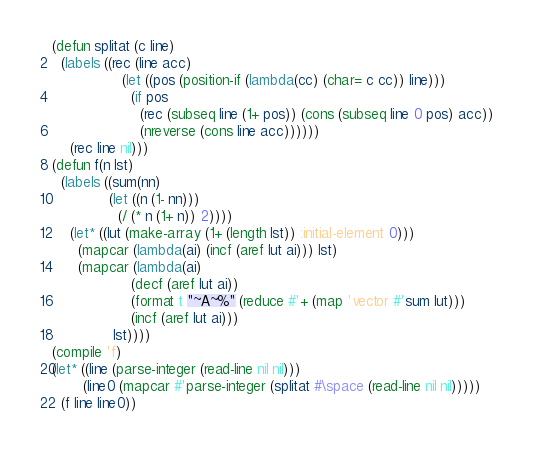Convert code to text. <code><loc_0><loc_0><loc_500><loc_500><_Lisp_>(defun splitat (c line)
  (labels ((rec (line acc)
                (let ((pos (position-if (lambda(cc) (char= c cc)) line)))
                  (if pos
                    (rec (subseq line (1+ pos)) (cons (subseq line 0 pos) acc))
                    (nreverse (cons line acc))))))
    (rec line nil)))
(defun f(n lst)
  (labels ((sum(nn)
             (let ((n (1- nn)))
               (/ (* n (1+ n)) 2))))
    (let* ((lut (make-array (1+ (length lst)) :initial-element 0)))
      (mapcar (lambda(ai) (incf (aref lut ai))) lst)
      (mapcar (lambda(ai)
                  (decf (aref lut ai))
                  (format t "~A~%" (reduce #'+ (map 'vector #'sum lut)))
                  (incf (aref lut ai)))
              lst))))
(compile 'f)
(let* ((line (parse-integer (read-line nil nil)))
       (line0 (mapcar #'parse-integer (splitat #\space (read-line nil nil)))))
  (f line line0))
</code> 